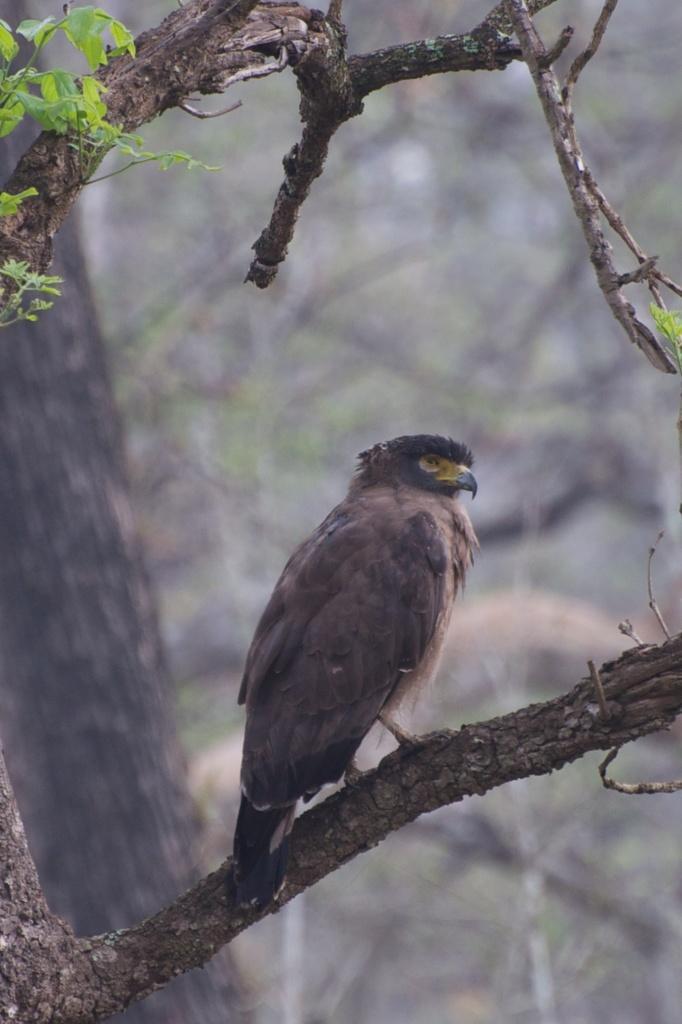In one or two sentences, can you explain what this image depicts? In this image, I can see a bird on a branch. On the left side of the image, I can see a tree trunk and the leaves. The background is blurry. 